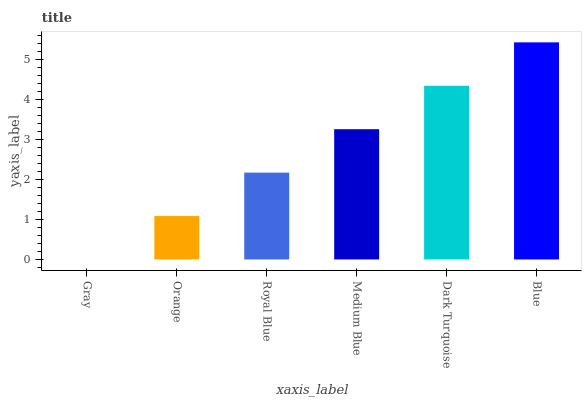Is Gray the minimum?
Answer yes or no. Yes. Is Blue the maximum?
Answer yes or no. Yes. Is Orange the minimum?
Answer yes or no. No. Is Orange the maximum?
Answer yes or no. No. Is Orange greater than Gray?
Answer yes or no. Yes. Is Gray less than Orange?
Answer yes or no. Yes. Is Gray greater than Orange?
Answer yes or no. No. Is Orange less than Gray?
Answer yes or no. No. Is Medium Blue the high median?
Answer yes or no. Yes. Is Royal Blue the low median?
Answer yes or no. Yes. Is Gray the high median?
Answer yes or no. No. Is Orange the low median?
Answer yes or no. No. 